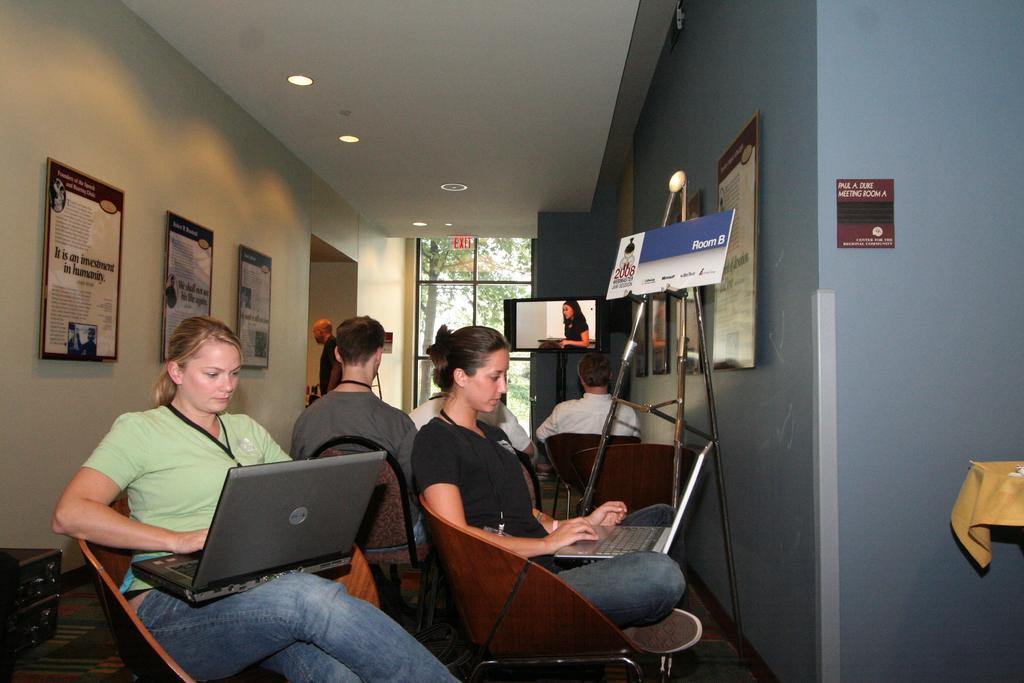In one or two sentences, can you explain what this image depicts? In this picture i could see many people sitting on the chair and working on a laptop. In the background i could see wall frames hanging on the wall and to the ceiling there are some lights, in the background i could see a window outside a window there is a tree 